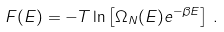Convert formula to latex. <formula><loc_0><loc_0><loc_500><loc_500>F ( E ) = - T \ln \left [ \Omega _ { N } ( E ) e ^ { - \beta E } \right ] \, .</formula> 